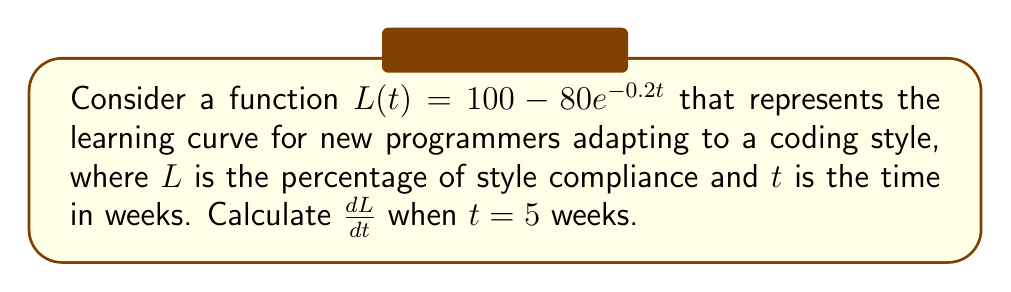Solve this math problem. To solve this problem, we need to follow these steps:

1) First, we need to find the derivative of $L(t)$ with respect to $t$.

   $L(t) = 100 - 80e^{-0.2t}$
   
   Using the chain rule, we get:
   
   $\frac{dL}{dt} = 0 - 80 \cdot (-0.2e^{-0.2t})$
   
   $\frac{dL}{dt} = 16e^{-0.2t}$

2) Now that we have the derivative, we need to evaluate it at $t = 5$.

   $\frac{dL}{dt}\big|_{t=5} = 16e^{-0.2(5)}$

3) Let's calculate this:

   $16e^{-1} \approx 16 \cdot 0.3679 \approx 5.8864$

Therefore, when $t = 5$ weeks, the rate of change in style compliance is approximately 5.8864% per week.
Answer: $16e^{-1} \approx 5.8864$ 